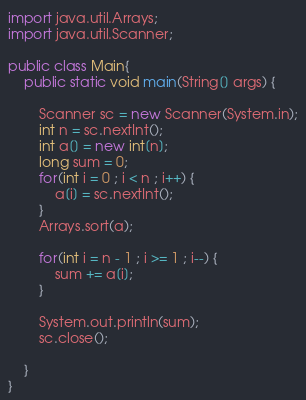Convert code to text. <code><loc_0><loc_0><loc_500><loc_500><_Java_>import java.util.Arrays;
import java.util.Scanner;

public class Main{
	public static void main(String[] args) {

		Scanner sc = new Scanner(System.in);
		int n = sc.nextInt();
		int a[] = new int[n];
		long sum = 0;
		for(int i = 0 ; i < n ; i++) {
			a[i] = sc.nextInt();
		}
		Arrays.sort(a);

		for(int i = n - 1 ; i >= 1 ; i--) {
			sum += a[i];
		}

		System.out.println(sum);
		sc.close();

	}
}

</code> 